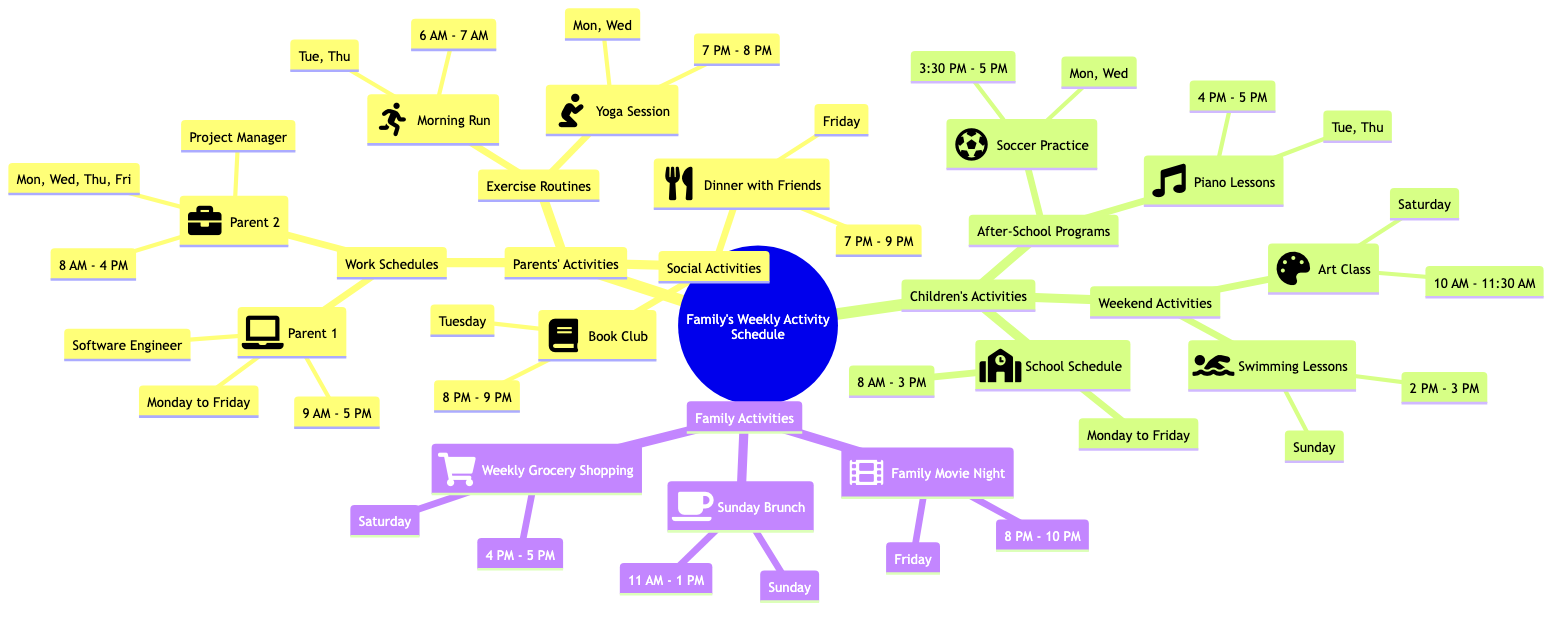What are the work days for Parent 1? Parent 1's work schedule specifies the days they work as Monday, Tuesday, Wednesday, Thursday, and Friday. These days are listed directly under Parent 1's node in the diagram.
Answer: Monday, Tuesday, Wednesday, Thursday, Friday What time does the Yoga Session take place? The Yoga Session is specifically mentioned under the Exercise Routines. It is scheduled for Monday and Wednesday from 7 PM to 8 PM. The time is provided next to the session within its node.
Answer: 7 PM - 8 PM How many weekend activities are listed? Weekend Activities consist of two entries: Art Class on Saturday and Swimming Lessons on Sunday. To determine the count, I must simply tally the activities listed under the Weekend Activities node.
Answer: 2 What is the overlap between Parents' Exercise Routines and Children's After-School Programs? The Parents' Exercise Routines and Children's After-School Programs show a specific overlap on Tuesday and Thursday, where the Morning Run overlaps with Piano Lessons. This intersection reveals the days that both types of activities occur simultaneously.
Answer: Tuesday, Thursday How many family activities occur on Sunday? The Family Activities section shows there is only one activity scheduled for Sunday, which is Sunday Brunch, occurring from 11 AM to 1 PM. This is determined by inspecting the Family Activities node for any entries listed on Sunday.
Answer: 1 